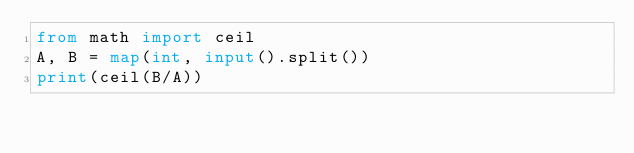Convert code to text. <code><loc_0><loc_0><loc_500><loc_500><_Python_>from math import ceil
A, B = map(int, input().split())
print(ceil(B/A))</code> 